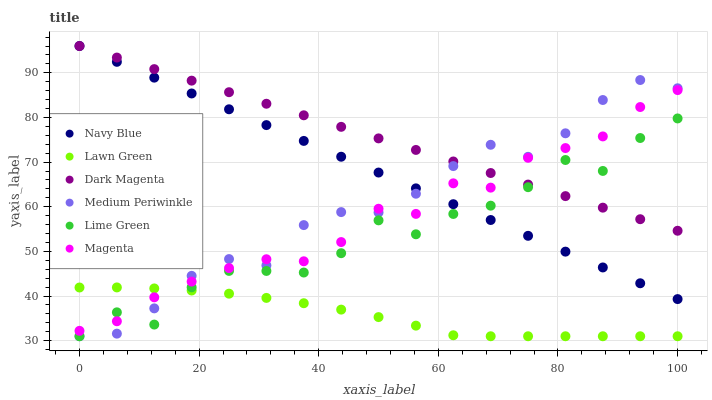Does Lawn Green have the minimum area under the curve?
Answer yes or no. Yes. Does Dark Magenta have the maximum area under the curve?
Answer yes or no. Yes. Does Navy Blue have the minimum area under the curve?
Answer yes or no. No. Does Navy Blue have the maximum area under the curve?
Answer yes or no. No. Is Dark Magenta the smoothest?
Answer yes or no. Yes. Is Lime Green the roughest?
Answer yes or no. Yes. Is Medium Periwinkle the smoothest?
Answer yes or no. No. Is Medium Periwinkle the roughest?
Answer yes or no. No. Does Lawn Green have the lowest value?
Answer yes or no. Yes. Does Navy Blue have the lowest value?
Answer yes or no. No. Does Navy Blue have the highest value?
Answer yes or no. Yes. Does Medium Periwinkle have the highest value?
Answer yes or no. No. Is Lawn Green less than Dark Magenta?
Answer yes or no. Yes. Is Dark Magenta greater than Lawn Green?
Answer yes or no. Yes. Does Medium Periwinkle intersect Magenta?
Answer yes or no. Yes. Is Medium Periwinkle less than Magenta?
Answer yes or no. No. Is Medium Periwinkle greater than Magenta?
Answer yes or no. No. Does Lawn Green intersect Dark Magenta?
Answer yes or no. No. 